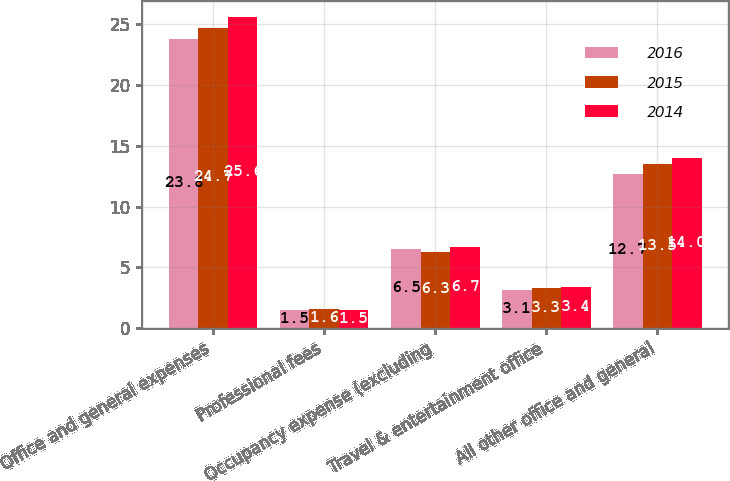<chart> <loc_0><loc_0><loc_500><loc_500><stacked_bar_chart><ecel><fcel>Office and general expenses<fcel>Professional fees<fcel>Occupancy expense (excluding<fcel>Travel & entertainment office<fcel>All other office and general<nl><fcel>2016<fcel>23.8<fcel>1.5<fcel>6.5<fcel>3.1<fcel>12.7<nl><fcel>2015<fcel>24.7<fcel>1.6<fcel>6.3<fcel>3.3<fcel>13.5<nl><fcel>2014<fcel>25.6<fcel>1.5<fcel>6.7<fcel>3.4<fcel>14<nl></chart> 